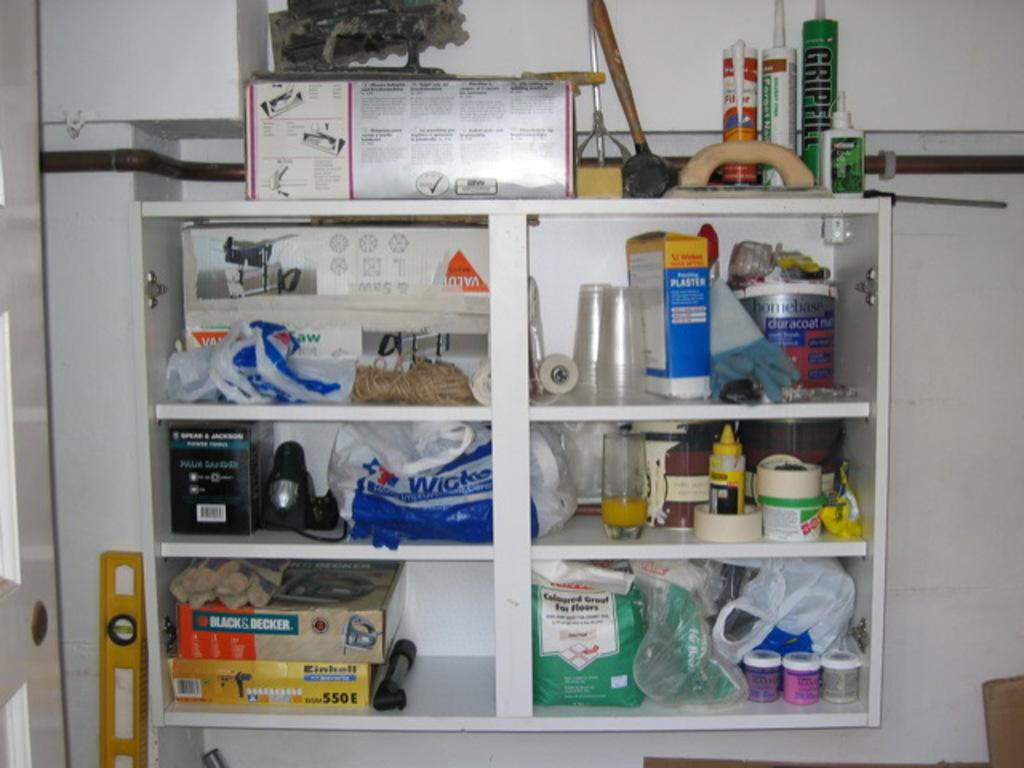<image>
Provide a brief description of the given image. A shelving unit that has a Black & Decker box on it. 